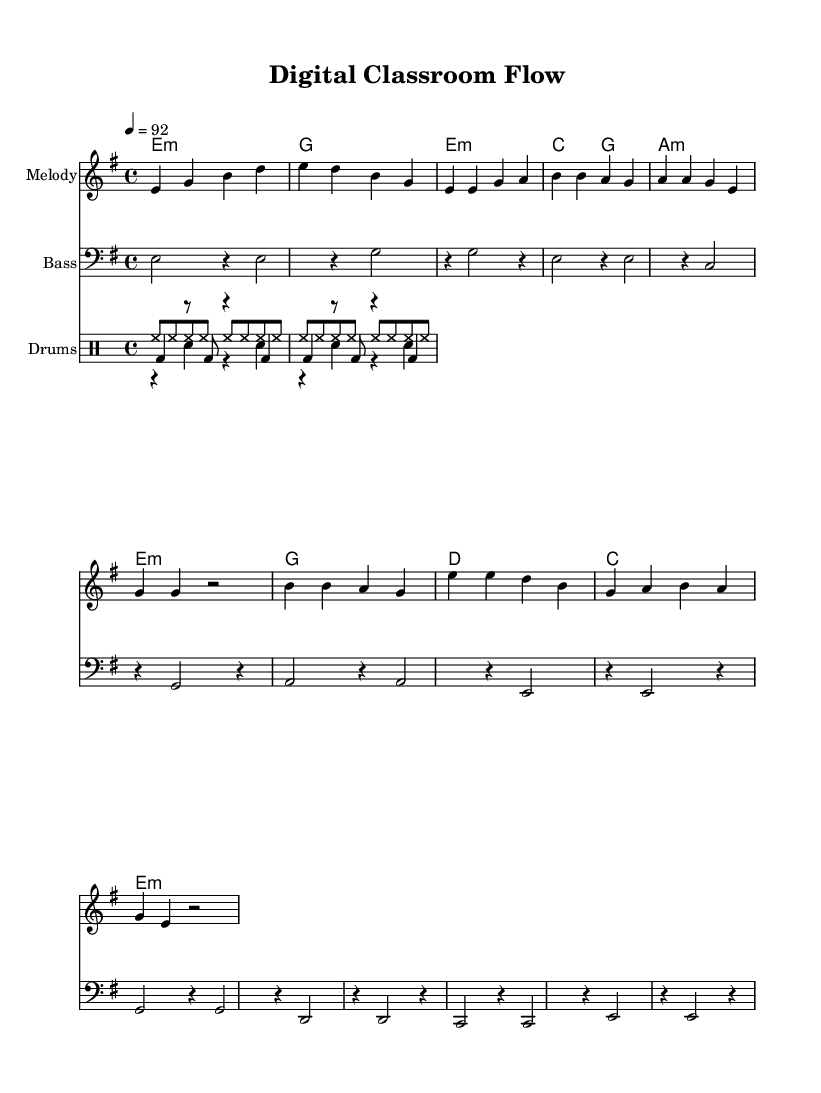What is the key signature of this music? The key signature is E minor, which has one sharp (F#). This is indicated at the beginning of the music, right after the clef.
Answer: E minor What is the time signature of this music? The time signature is 4/4, which is shown at the start of the score. This means there are four beats in a measure and the quarter note gets one beat.
Answer: 4/4 What is the tempo marking for this piece? The tempo marking is quarter note equals 92, which indicates the speed at which the music should be played. This is found at the beginning of the score.
Answer: 92 How many measures are in the chorus section? The chorus section consists of four measures, as evident from the grouped measures that follow the verse section. Each measure can be counted visually on the score.
Answer: 4 What recurring rhythmic pattern is used in the drum section? A consistent eighth note hi-hat pattern is displayed in the drum staff, which acts as a common element in rap music, providing a steady beat. This can be seen where "hh" is notated.
Answer: Hi-hat pattern Which instrument plays the bassline in this score? The bassline is played by a staff labeled "Bass," indicating the clef used for lower pitches. This label helps define the role of this staff in the overall arrangement.
Answer: Bass What type of chord progression is primarily used in the introduction? The introduction features a minor chord progression (e minor to g major), common in rap music for its dramatic effect, as indicated by the chord names under the melody.
Answer: Minor chord progression 